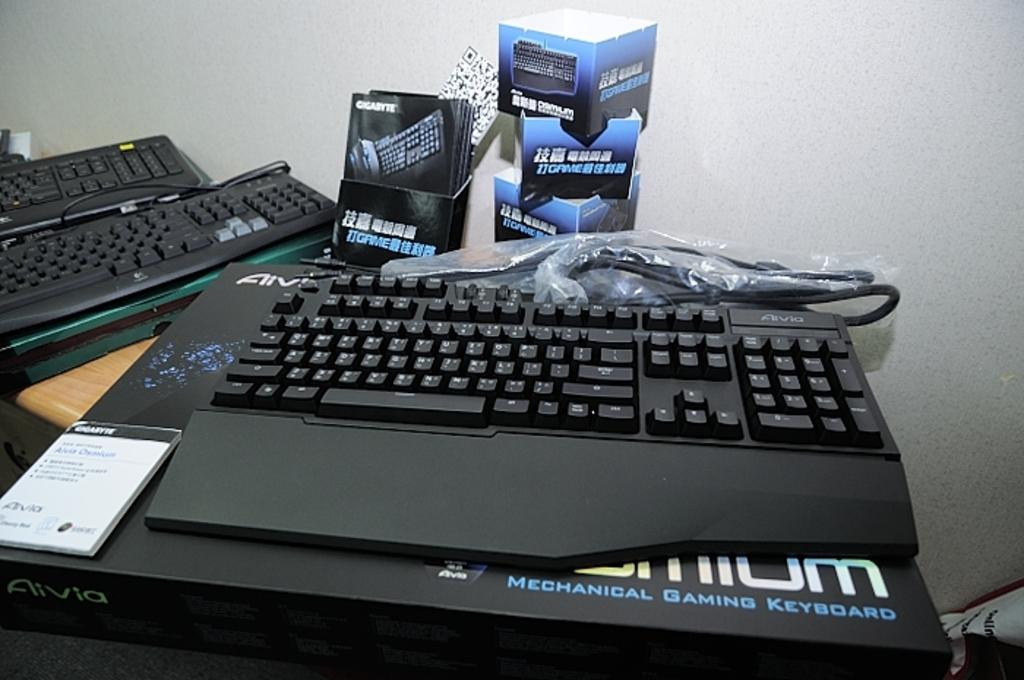<image>
Render a clear and concise summary of the photo. A mechanical gaming keyboard sits on a desk beside two other keyboards and packaging. 